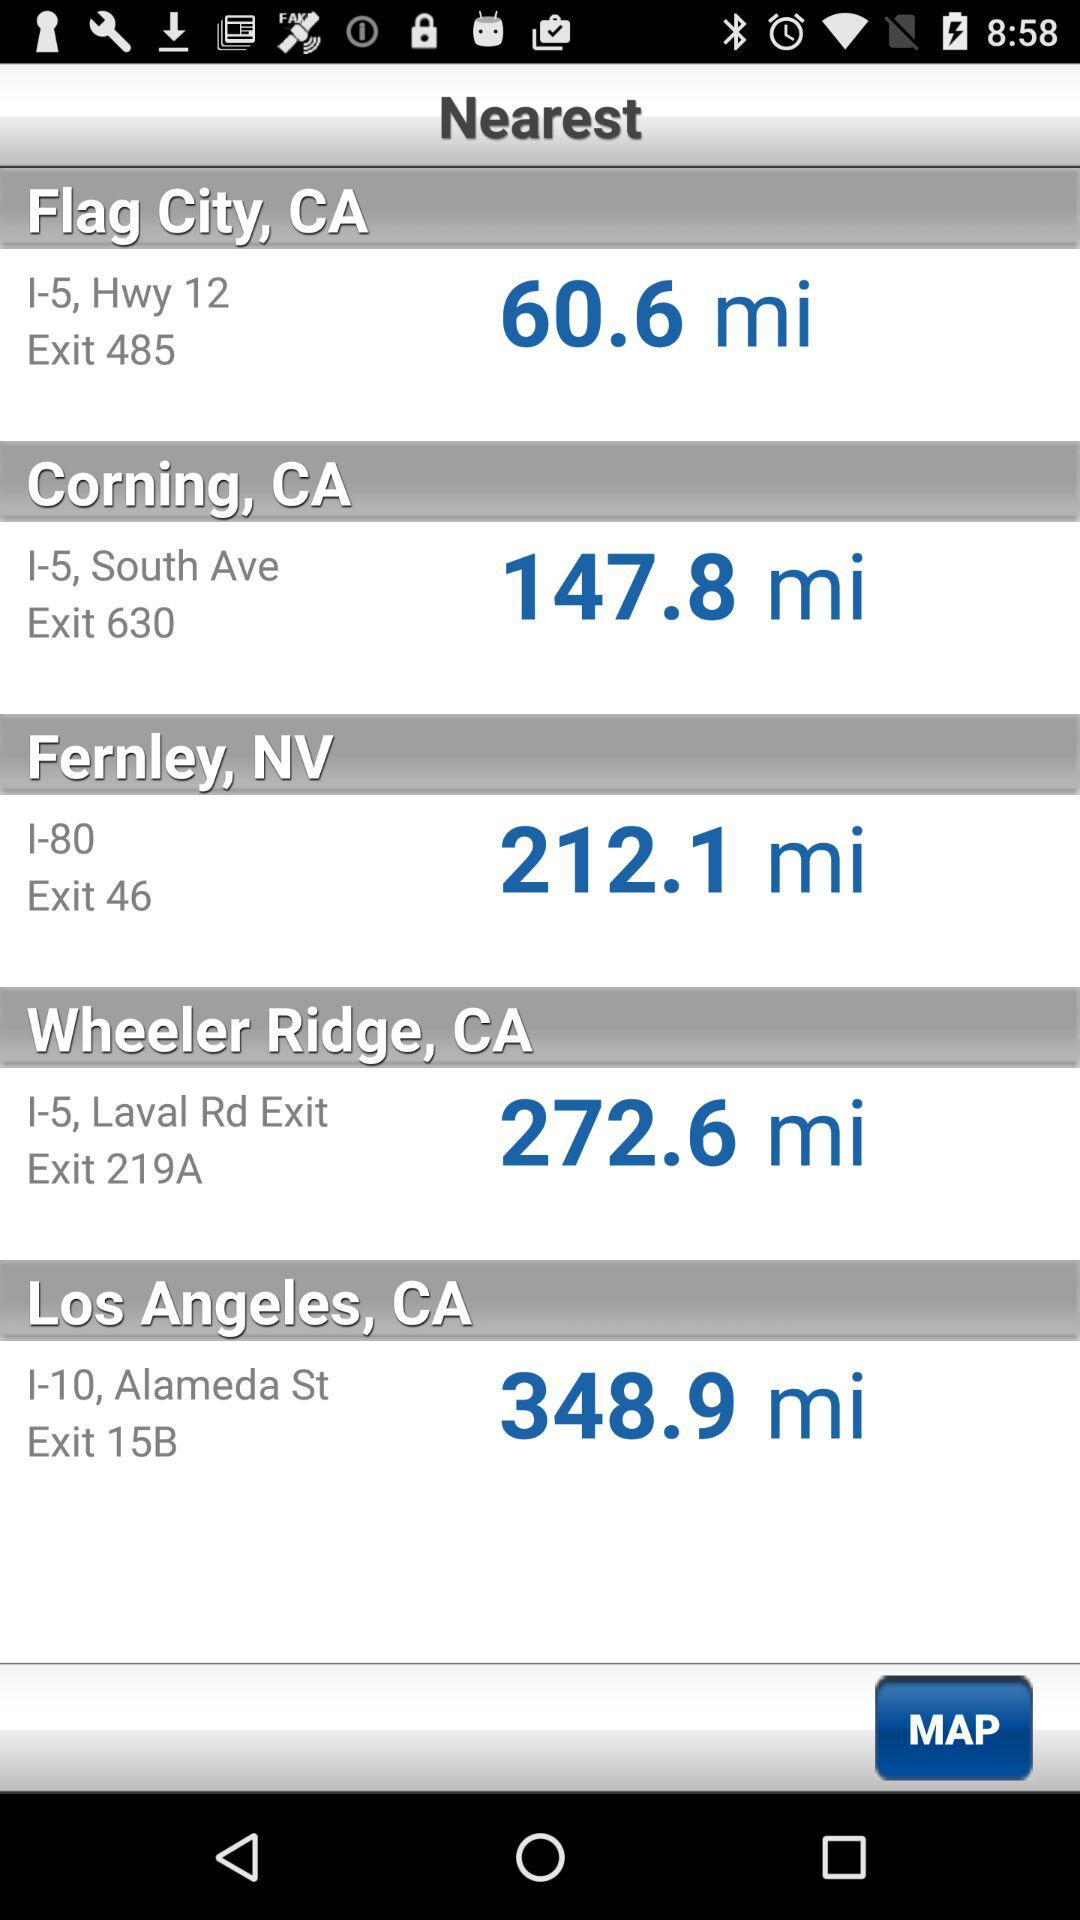What is the exit for Corning City? The exit for Corning City is 630. 